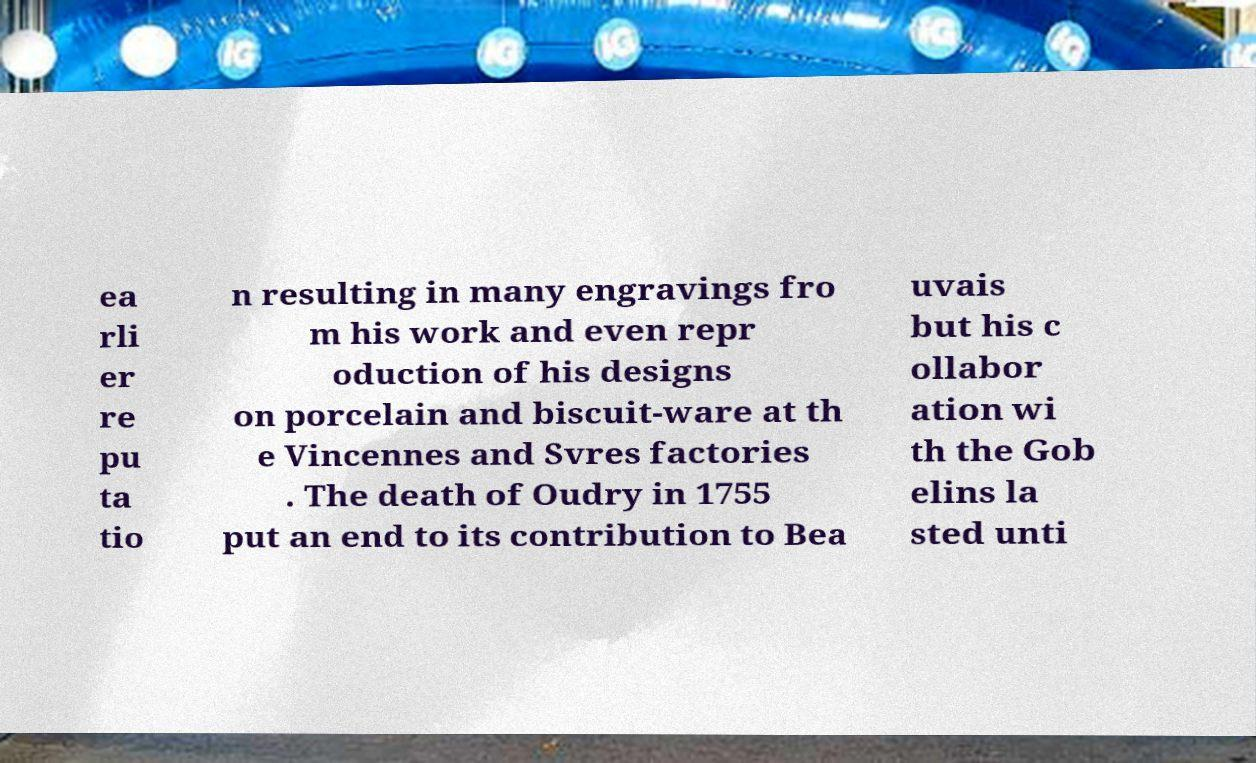Please read and relay the text visible in this image. What does it say? ea rli er re pu ta tio n resulting in many engravings fro m his work and even repr oduction of his designs on porcelain and biscuit-ware at th e Vincennes and Svres factories . The death of Oudry in 1755 put an end to its contribution to Bea uvais but his c ollabor ation wi th the Gob elins la sted unti 